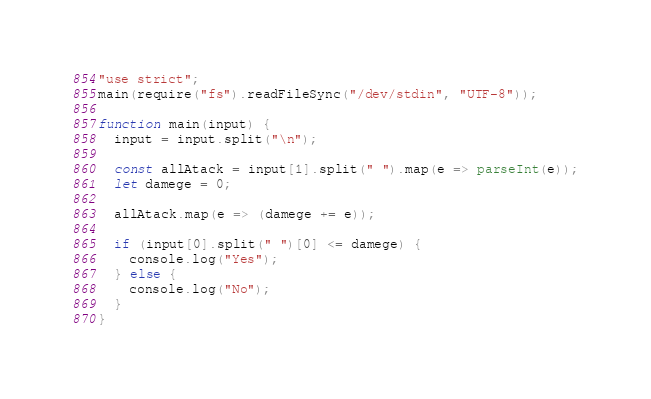<code> <loc_0><loc_0><loc_500><loc_500><_JavaScript_>"use strict";
main(require("fs").readFileSync("/dev/stdin", "UTF-8"));

function main(input) {
  input = input.split("\n");

  const allAtack = input[1].split(" ").map(e => parseInt(e));
  let damege = 0;

  allAtack.map(e => (damege += e));

  if (input[0].split(" ")[0] <= damege) {
    console.log("Yes");
  } else {
    console.log("No");
  }
}
</code> 